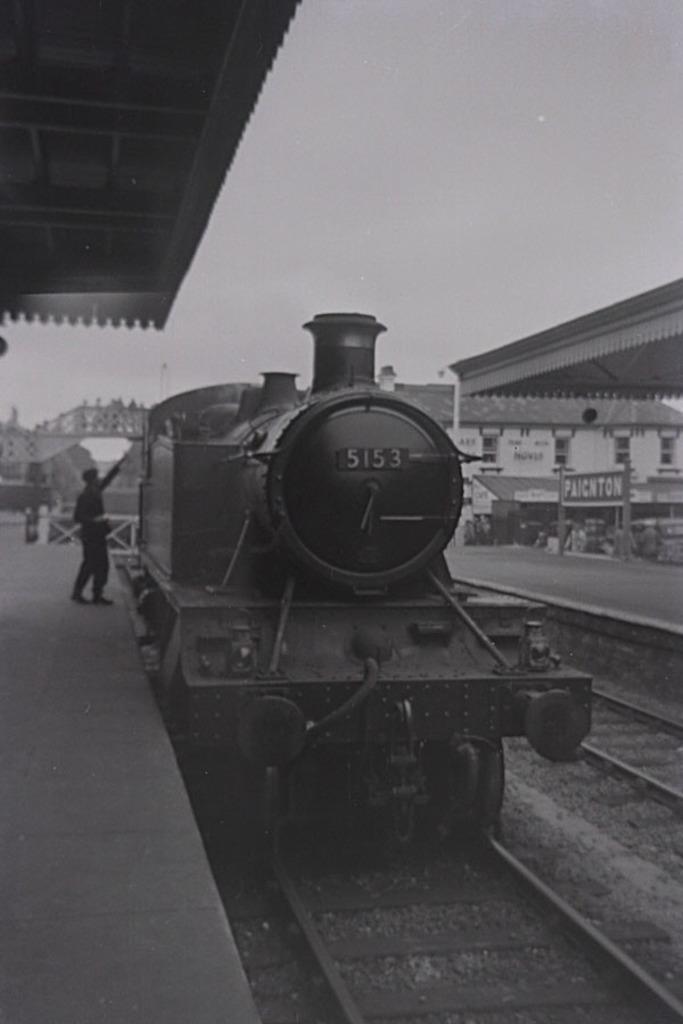Describe this image in one or two sentences. In this picture there is a train on the railway track. On the left side of the image there is a person standing on the platform. At the back there are buildings. On the right side of the image there is a board on the pole and there is text on the board. At the top there is sky. At the bottom there are railway tracks and there are stones. 